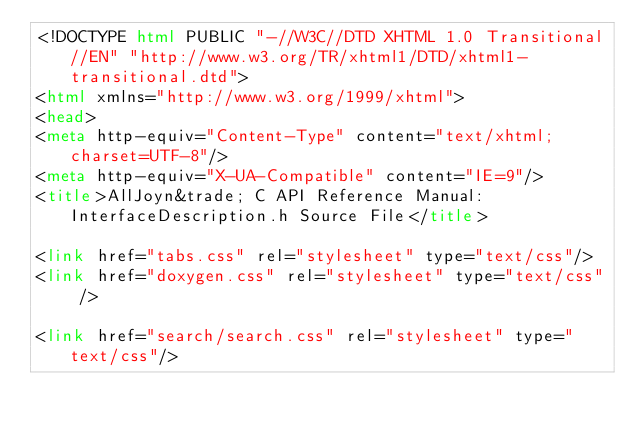<code> <loc_0><loc_0><loc_500><loc_500><_HTML_><!DOCTYPE html PUBLIC "-//W3C//DTD XHTML 1.0 Transitional//EN" "http://www.w3.org/TR/xhtml1/DTD/xhtml1-transitional.dtd">
<html xmlns="http://www.w3.org/1999/xhtml">
<head>
<meta http-equiv="Content-Type" content="text/xhtml;charset=UTF-8"/>
<meta http-equiv="X-UA-Compatible" content="IE=9"/>
<title>AllJoyn&trade; C API Reference Manual: InterfaceDescription.h Source File</title>

<link href="tabs.css" rel="stylesheet" type="text/css"/>
<link href="doxygen.css" rel="stylesheet" type="text/css" />

<link href="search/search.css" rel="stylesheet" type="text/css"/></code> 